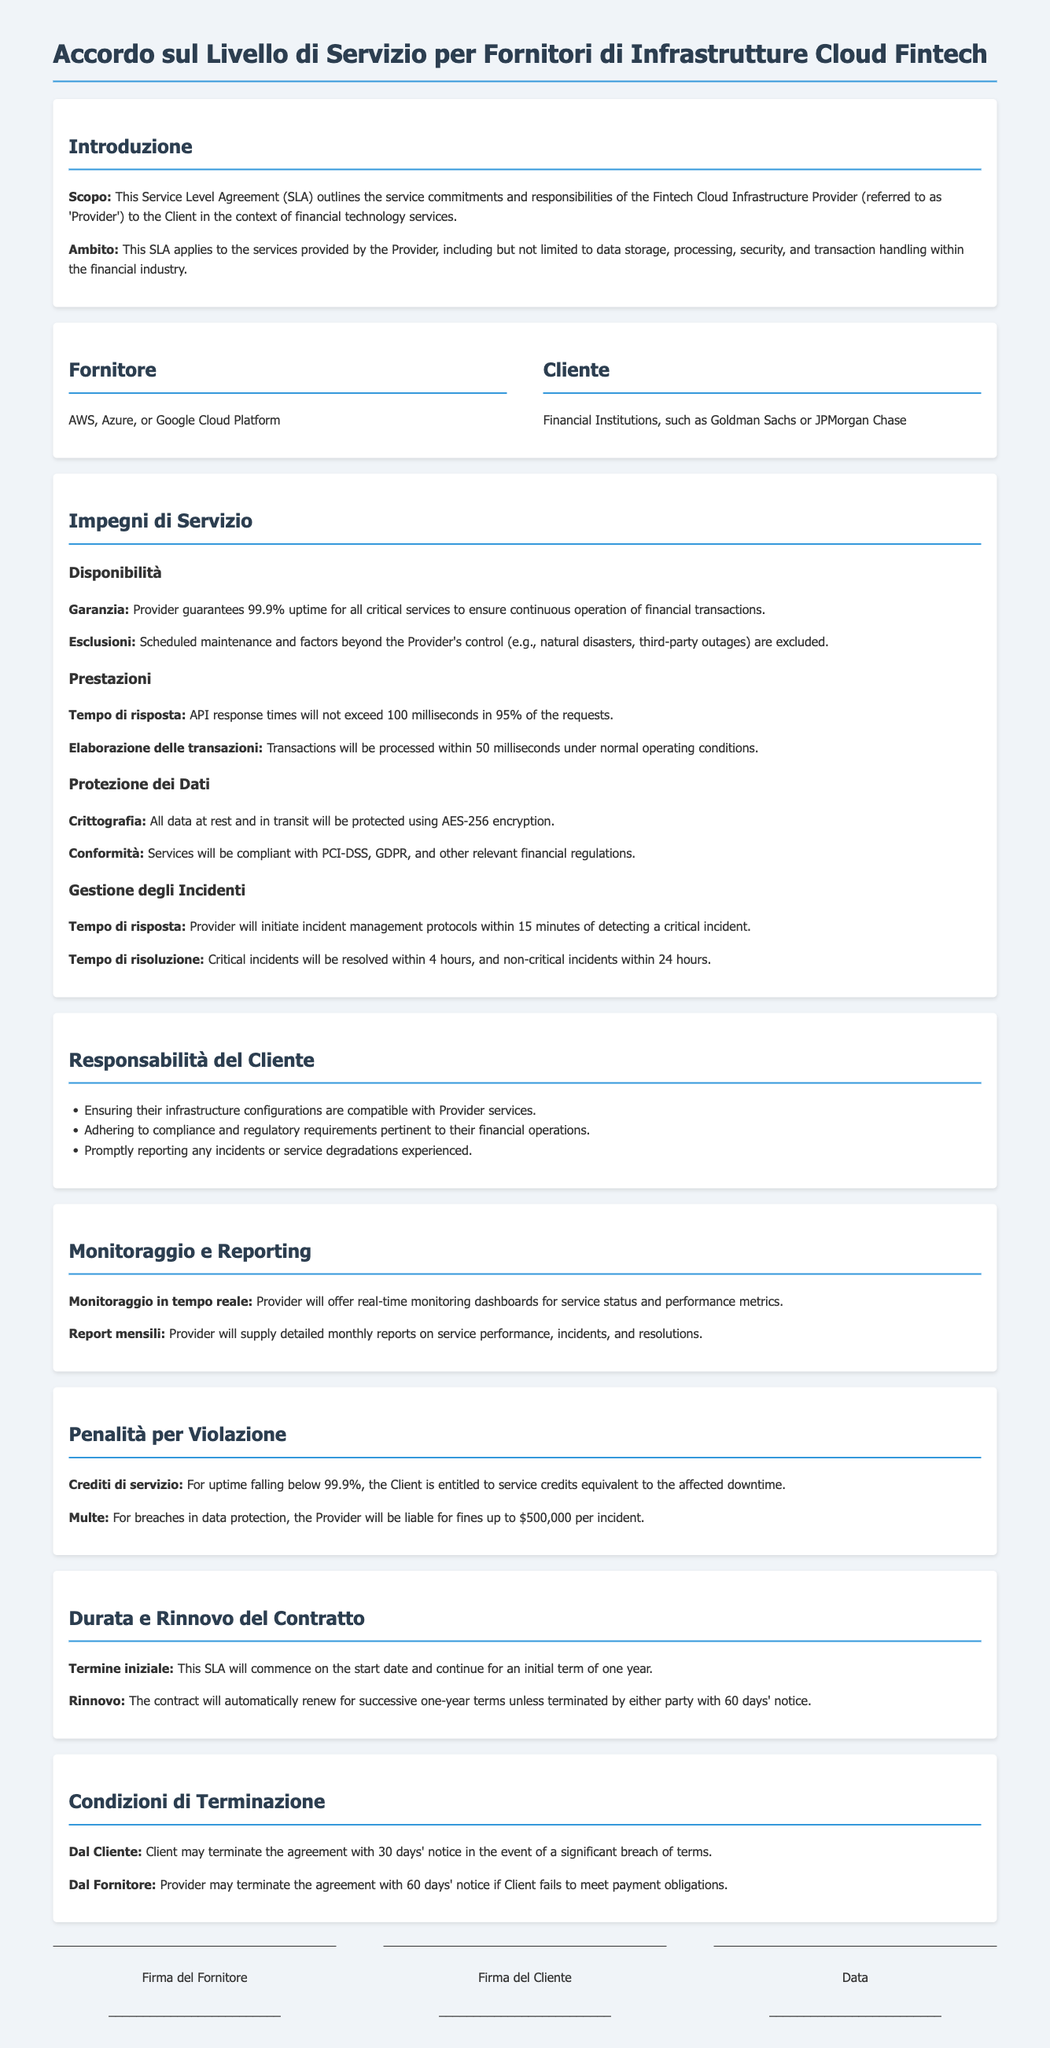what is the uptime guarantee provided by the Provider? The uptime guarantee is specified as 99.9% for all critical services to ensure continuous operation of financial transactions.
Answer: 99.9% what is the maximum API response time allowed? The maximum API response time is stipulated as not exceeding 100 milliseconds in 95% of the requests.
Answer: 100 milliseconds which regulations must the services comply with? The services must be compliant with PCI-DSS, GDPR, and other relevant financial regulations.
Answer: PCI-DSS, GDPR how long does the Provider have to resolve critical incidents? The time frame for resolving critical incidents is defined as within 4 hours.
Answer: 4 hours who can terminate the agreement with 30 days' notice? The Client is allowed to terminate the agreement with 30 days' notice in the event of a significant breach of terms.
Answer: Client what is included in the monthly reports provided to the Client? The monthly reports detail service performance, incidents, and resolutions.
Answer: service performance, incidents, resolutions what happens if the uptime falls below the guarantee? If uptime falls below the guarantee, the Client is entitled to service credits equivalent to the affected downtime.
Answer: service credits how long is the initial term of the SLA? The initial term of the SLA is established to be one year.
Answer: one year what encryption standard is used to protect data? The standard for protecting data is identified as AES-256 encryption.
Answer: AES-256 encryption 